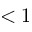<formula> <loc_0><loc_0><loc_500><loc_500>< 1</formula> 